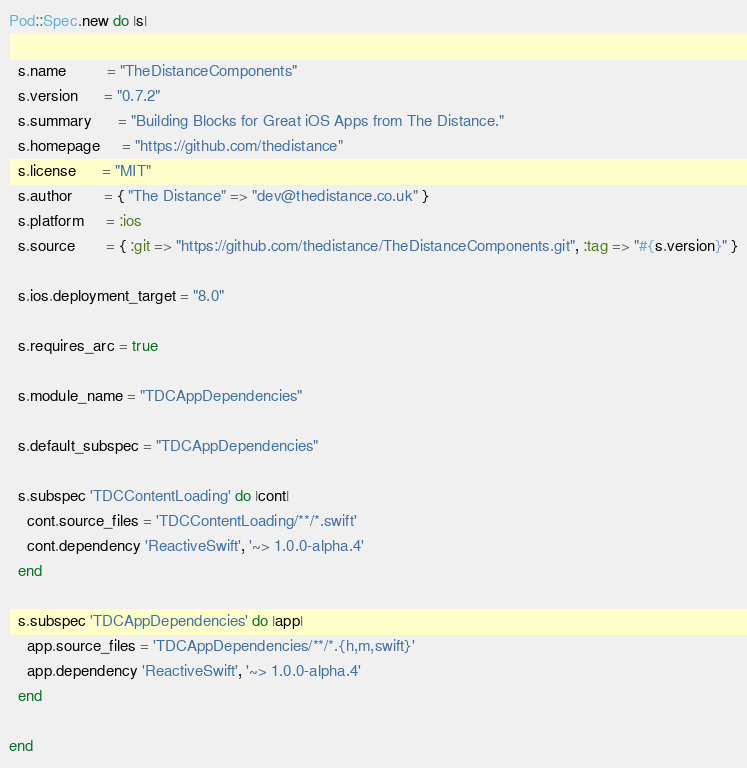<code> <loc_0><loc_0><loc_500><loc_500><_Ruby_>Pod::Spec.new do |s|

  s.name         = "TheDistanceComponents"
  s.version      = "0.7.2"
  s.summary      = "Building Blocks for Great iOS Apps from The Distance."
  s.homepage     = "https://github.com/thedistance"
  s.license      = "MIT"
  s.author       = { "The Distance" => "dev@thedistance.co.uk" }
  s.platform     = :ios
  s.source       = { :git => "https://github.com/thedistance/TheDistanceComponents.git", :tag => "#{s.version}" }

  s.ios.deployment_target = "8.0"

  s.requires_arc = true
  
  s.module_name = "TDCAppDependencies"
    
  s.default_subspec = "TDCAppDependencies"
  
  s.subspec 'TDCContentLoading' do |cont|
    cont.source_files = 'TDCContentLoading/**/*.swift'
    cont.dependency 'ReactiveSwift', '~> 1.0.0-alpha.4'
  end  
  
  s.subspec 'TDCAppDependencies' do |app|
    app.source_files = 'TDCAppDependencies/**/*.{h,m,swift}'
    app.dependency 'ReactiveSwift', '~> 1.0.0-alpha.4'
  end  

end
</code> 